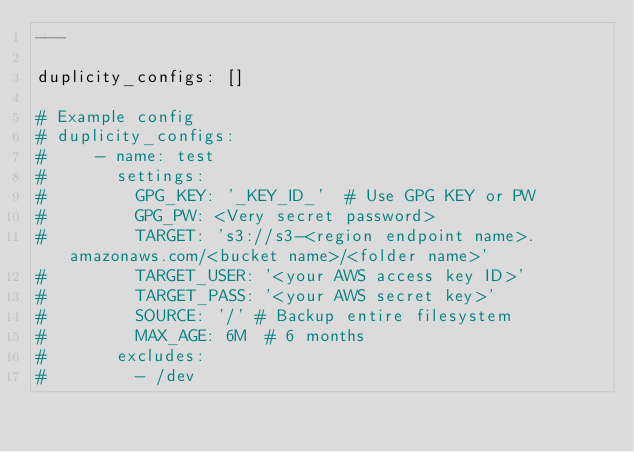Convert code to text. <code><loc_0><loc_0><loc_500><loc_500><_YAML_>---

duplicity_configs: []

# Example config
# duplicity_configs:
#     - name: test
#       settings:
#         GPG_KEY: '_KEY_ID_'  # Use GPG KEY or PW
#         GPG_PW: <Very secret password>
#         TARGET: 's3://s3-<region endpoint name>.amazonaws.com/<bucket name>/<folder name>'
#         TARGET_USER: '<your AWS access key ID>'
#         TARGET_PASS: '<your AWS secret key>'
#         SOURCE: '/' # Backup entire filesystem
#         MAX_AGE: 6M  # 6 months
#       excludes:
#         - /dev</code> 